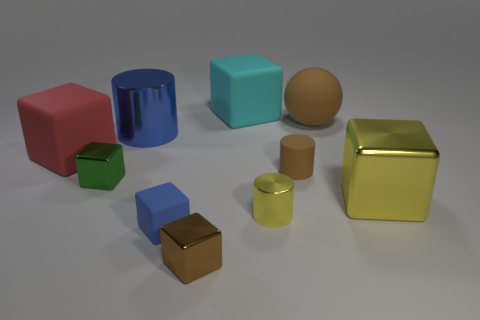Is there a cylinder of the same size as the blue rubber object?
Provide a short and direct response. Yes. There is a small cylinder that is the same material as the big blue cylinder; what color is it?
Your answer should be very brief. Yellow. What is the material of the big red block?
Make the answer very short. Rubber. There is a cyan object; what shape is it?
Offer a terse response. Cube. What number of small metallic cubes have the same color as the large ball?
Keep it short and to the point. 1. What material is the large cube left of the object behind the big matte thing to the right of the large cyan block?
Offer a terse response. Rubber. How many brown objects are either shiny cubes or small matte cubes?
Make the answer very short. 1. What is the size of the metallic cylinder that is on the left side of the cube that is behind the large matte thing that is in front of the large matte sphere?
Give a very brief answer. Large. There is a green shiny object that is the same shape as the red rubber object; what size is it?
Give a very brief answer. Small. What number of tiny things are either cylinders or blocks?
Offer a very short reply. 5. 